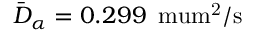Convert formula to latex. <formula><loc_0><loc_0><loc_500><loc_500>\bar { D } _ { \alpha } = 0 . 2 9 9 \, { \ m u m ^ { 2 } / s }</formula> 